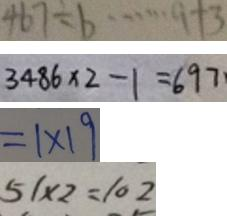<formula> <loc_0><loc_0><loc_500><loc_500>4 6 7 \div b \cdots 9 + 3 
 3 4 8 6 \times 2 - 1 = 6 9 7 \cdot 
 = 1 \times 1 9 
 5 1 \times 2 = 1 0 2</formula> 